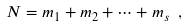Convert formula to latex. <formula><loc_0><loc_0><loc_500><loc_500>N = m _ { 1 } + m _ { 2 } + \cdots + m _ { s } \ ,</formula> 